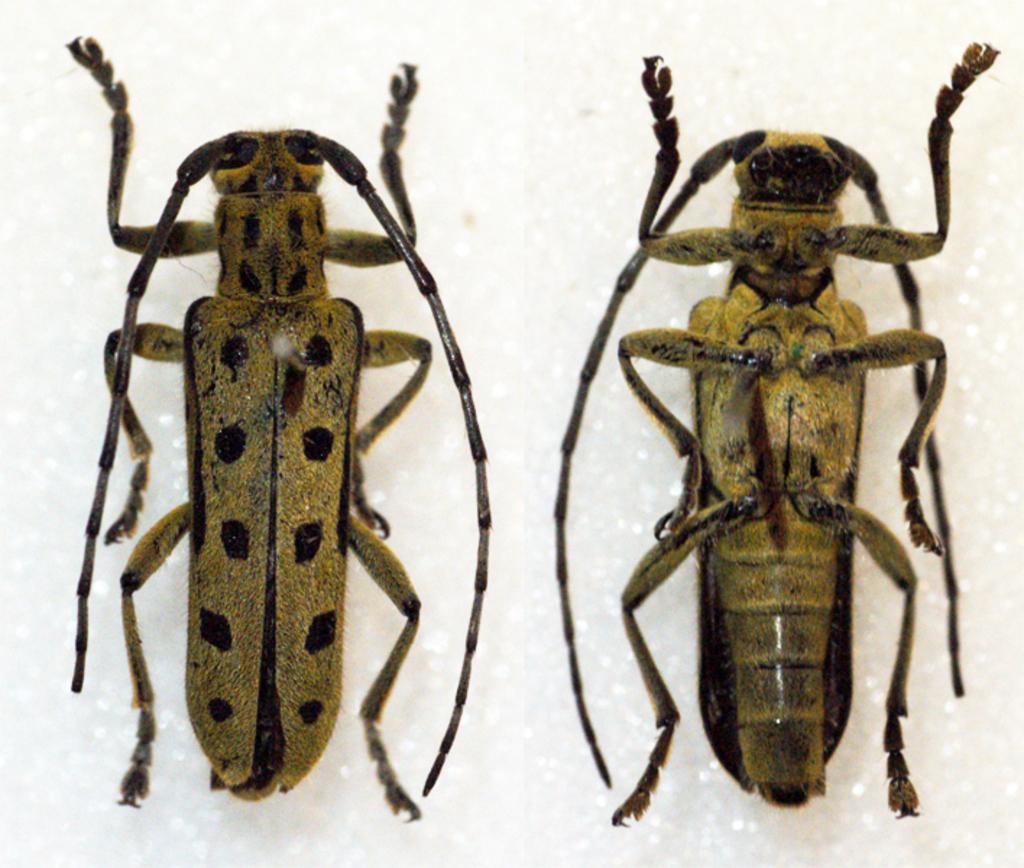In one or two sentences, can you explain what this image depicts? In this image, we can see cockroaches. Background we can see a white color. 